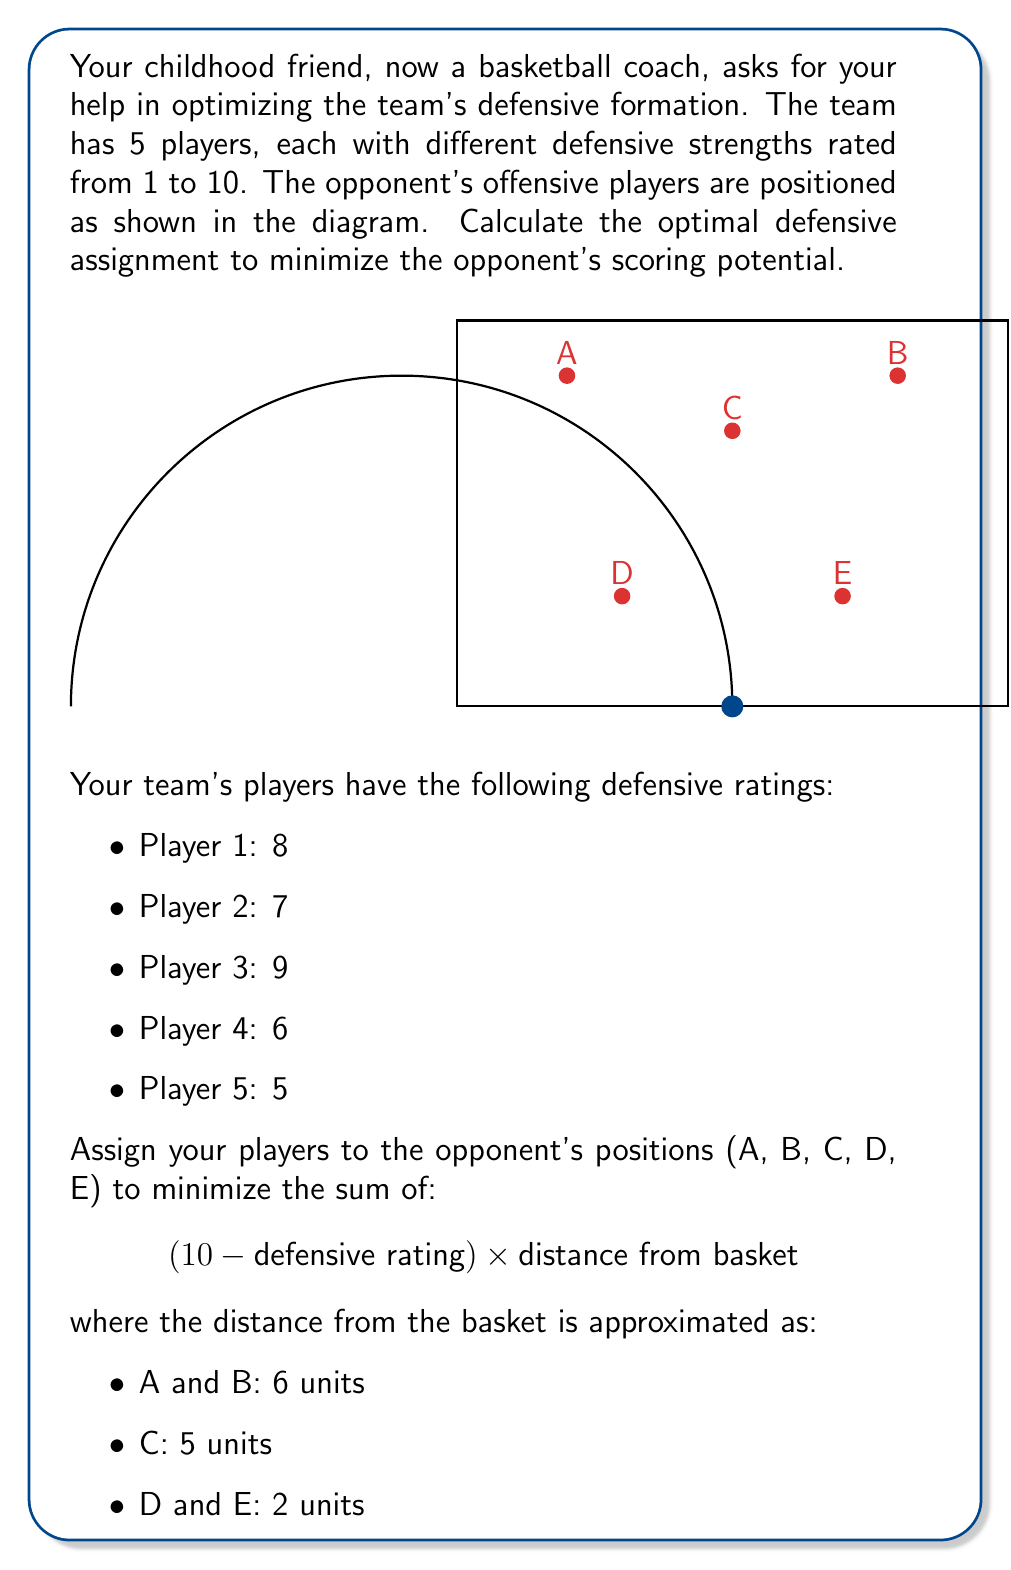Could you help me with this problem? To solve this optimization problem, we need to consider all possible assignments and calculate the total score for each. The lower the score, the better the defensive formation.

Step 1: Calculate the individual scores for each player at each position.
For each position, we calculate (10 - defensive rating) × distance:

A and B (6 units from basket):
Player 1: (10 - 8) × 6 = 12
Player 2: (10 - 7) × 6 = 18
Player 3: (10 - 9) × 6 = 6
Player 4: (10 - 6) × 6 = 24
Player 5: (10 - 5) × 6 = 30

C (5 units from basket):
Player 1: (10 - 8) × 5 = 10
Player 2: (10 - 7) × 5 = 15
Player 3: (10 - 9) × 5 = 5
Player 4: (10 - 6) × 5 = 20
Player 5: (10 - 5) × 5 = 25

D and E (2 units from basket):
Player 1: (10 - 8) × 2 = 4
Player 2: (10 - 7) × 2 = 6
Player 3: (10 - 9) × 2 = 2
Player 4: (10 - 6) × 2 = 8
Player 5: (10 - 5) × 2 = 10

Step 2: Find the optimal assignment.
We need to assign each player to a unique position. The best strategy is to put the strongest defenders (lowest scores) at positions furthest from the basket.

Optimal assignment:
Player 3 (strongest) → A
Player 1 (second strongest) → B
Player 2 (third strongest) → C
Player 4 (fourth strongest) → D
Player 5 (weakest) → E

Step 3: Calculate the total score.
Total score = 6 + 12 + 15 + 8 + 10 = 51

This assignment minimizes the opponent's scoring potential based on our defensive ratings and the opponents' positions.
Answer: Optimal assignment: 3→A, 1→B, 2→C, 4→D, 5→E; Total score: 51 